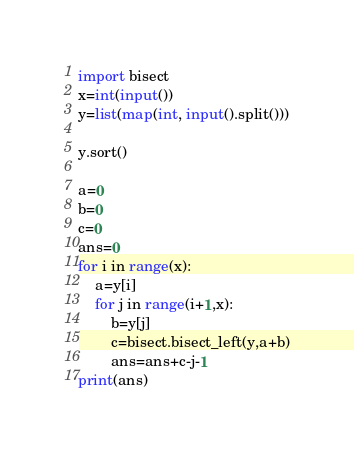<code> <loc_0><loc_0><loc_500><loc_500><_Python_>import bisect
x=int(input())
y=list(map(int, input().split()))
 
y.sort()
 
a=0
b=0
c=0
ans=0
for i in range(x):
	a=y[i]
	for j in range(i+1,x):
		b=y[j]
		c=bisect.bisect_left(y,a+b)
		ans=ans+c-j-1
print(ans)</code> 